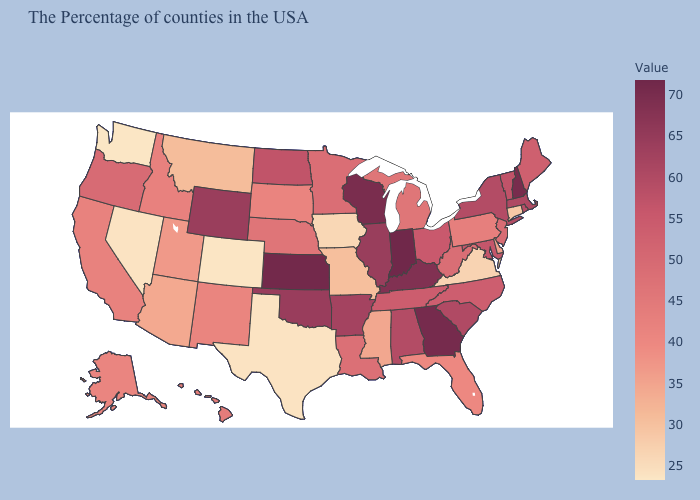Among the states that border Indiana , which have the highest value?
Be succinct. Kentucky. Among the states that border Virginia , which have the lowest value?
Keep it brief. West Virginia. Does Indiana have the highest value in the MidWest?
Be succinct. Yes. Does Montana have the highest value in the West?
Quick response, please. No. 